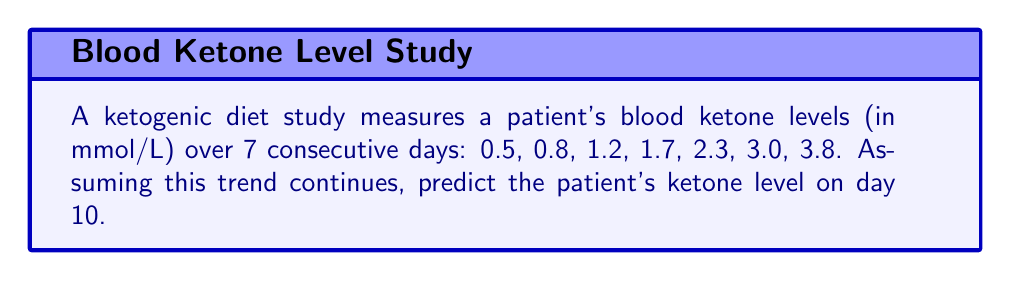Can you solve this math problem? To predict the ketone level on day 10, we need to identify the pattern in the given sequence and extend it. Let's analyze the differences between consecutive terms:

1. Calculate the differences:
   $0.8 - 0.5 = 0.3$
   $1.2 - 0.8 = 0.4$
   $1.7 - 1.2 = 0.5$
   $2.3 - 1.7 = 0.6$
   $3.0 - 2.3 = 0.7$
   $3.8 - 3.0 = 0.8$

2. Observe that the differences form an arithmetic sequence: 0.3, 0.4, 0.5, 0.6, 0.7, 0.8
   The common difference of this sequence is 0.1

3. Extend the sequence of differences for days 8, 9, and 10:
   Day 8: 0.9
   Day 9: 1.0
   Day 10: 1.1

4. Calculate the ketone levels for days 8, 9, and 10:
   Day 8: $3.8 + 0.9 = 4.7$ mmol/L
   Day 9: $4.7 + 1.0 = 5.7$ mmol/L
   Day 10: $5.7 + 1.1 = 6.8$ mmol/L

Therefore, the predicted ketone level on day 10 is 6.8 mmol/L.
Answer: 6.8 mmol/L 